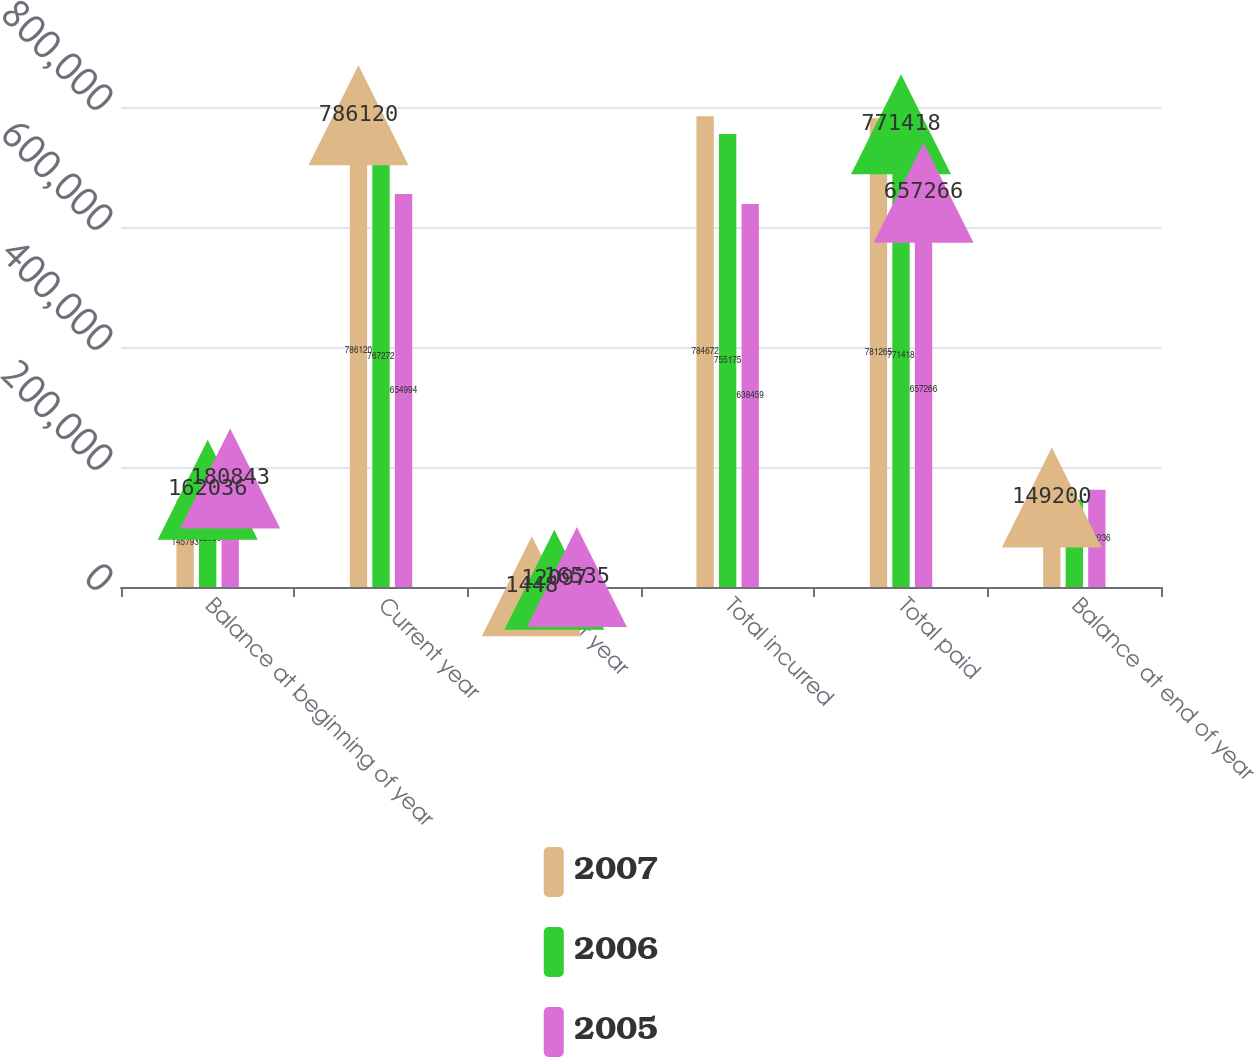Convert chart. <chart><loc_0><loc_0><loc_500><loc_500><stacked_bar_chart><ecel><fcel>Balance at beginning of year<fcel>Current year<fcel>Prior year<fcel>Total incurred<fcel>Total paid<fcel>Balance at end of year<nl><fcel>2007<fcel>145793<fcel>786120<fcel>1448<fcel>784672<fcel>781265<fcel>149200<nl><fcel>2006<fcel>162036<fcel>767272<fcel>12097<fcel>755175<fcel>771418<fcel>145793<nl><fcel>2005<fcel>180843<fcel>654994<fcel>16535<fcel>638459<fcel>657266<fcel>162036<nl></chart> 